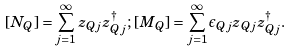Convert formula to latex. <formula><loc_0><loc_0><loc_500><loc_500>[ N _ { Q } ] = \sum _ { j = 1 } ^ { \infty } z _ { Q j } z _ { Q j } ^ { \dagger } ; \, [ M _ { Q } ] = \sum _ { j = 1 } ^ { \infty } \epsilon _ { Q j } z _ { Q j } z _ { Q j } ^ { \dagger } .</formula> 